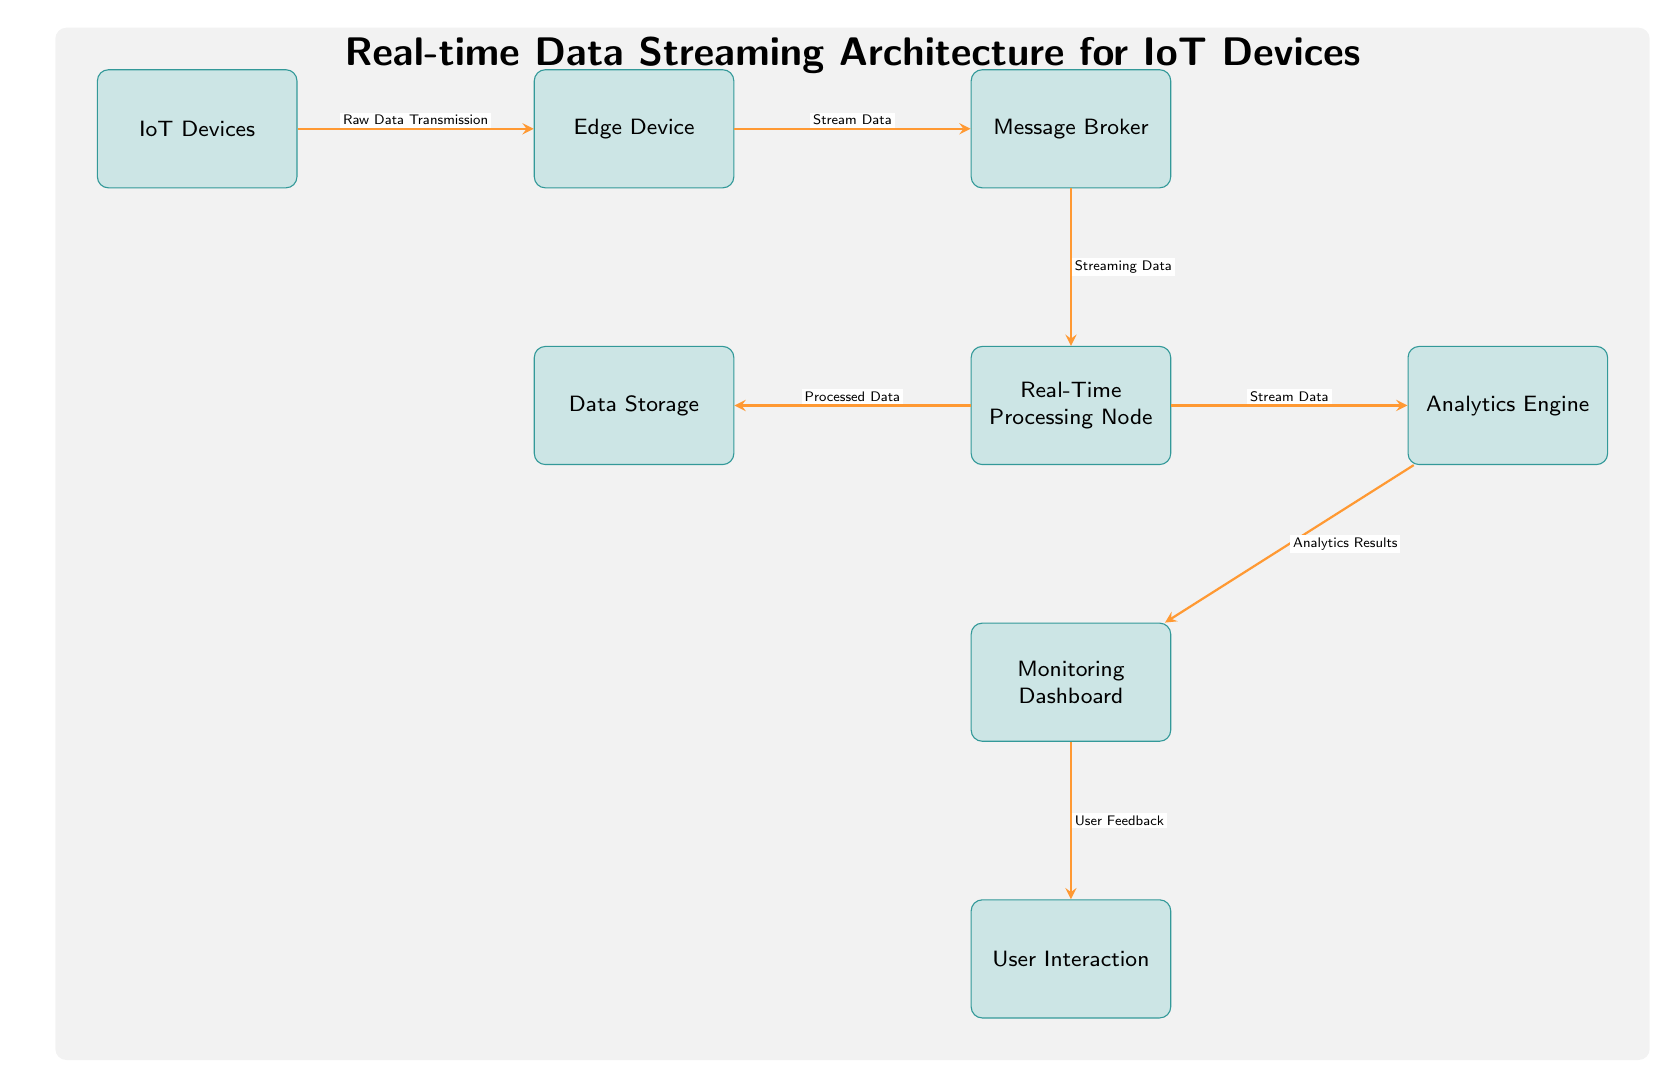What is the first node in the data flow? The first node is identified by its position at the far left of the diagram, where data begins its transmission. It is labeled as "IoT Devices."
Answer: IoT Devices How many processing nodes are present in the diagram? The single processing node can be located directly below the "Message Broker," as labeled in the diagram. Hence, there is only one processing node.
Answer: 1 What data is transmitted from the Edge Device to the Message Broker? The label on the arrow connecting the "Edge Device" to the "Message Broker" specifies what is being transmitted as "Stream Data."
Answer: Stream Data What is the relationship between the Real-Time Processing Node and Data Storage? The diagram indicates the flow of processed data from the "Real-Time Processing Node" to "Data Storage," confirming their operational relationship.
Answer: Processed Data From which node does the analytics engine receive data? By following the arrow from the "Real-Time Processing Node" to the "Analytics Engine," it is clear that the data being sent is "Stream Data."
Answer: Real-Time Processing Node What is the purpose of the Monitoring Dashboard in this architecture? The "Monitoring Dashboard" receives "Analytics Results" from the "Analytics Engine," showing its purpose as the visual representation of analytical outcomes.
Answer: Analytics Results Which component directly interacts with the User? Tracing down from the "Monitoring Dashboard," which outputs "User Feedback," we find that the component directly interacting with the user is the "User Interaction" node itself.
Answer: User Interaction What type of feedback does the User provide to the system? The relationship between the "Monitoring Dashboard" and "User Interaction" explicitly describes this as "User Feedback."
Answer: User Feedback What does the arrow indicate between the Real-Time Processing Node and Analytics Engine? The arrow leads from the "Real-Time Processing Node" to the "Analytics Engine," and is labeled as "Stream Data," indicating that this is the type of data being transferred.
Answer: Stream Data 